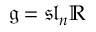<formula> <loc_0><loc_0><loc_500><loc_500>{ \mathfrak { g } } = { \mathfrak { s l } } _ { n } \mathbb { R }</formula> 